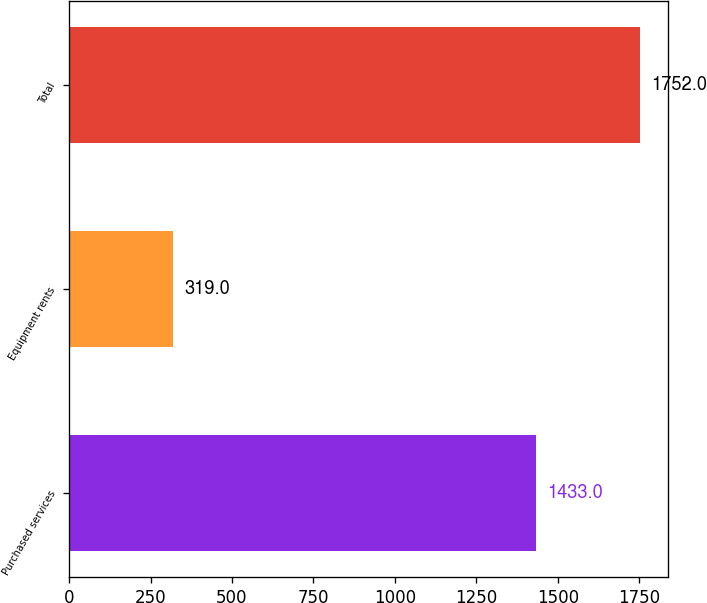<chart> <loc_0><loc_0><loc_500><loc_500><bar_chart><fcel>Purchased services<fcel>Equipment rents<fcel>Total<nl><fcel>1433<fcel>319<fcel>1752<nl></chart> 